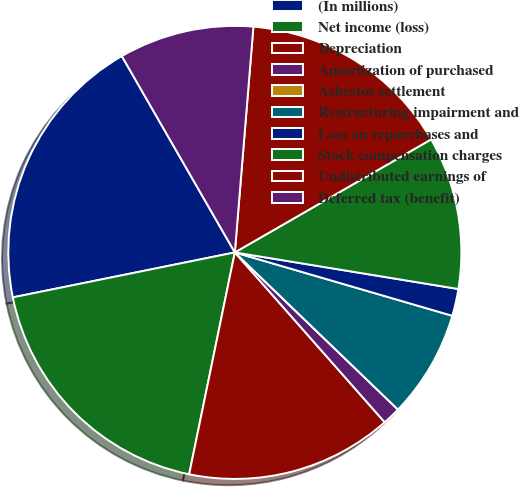Convert chart to OTSL. <chart><loc_0><loc_0><loc_500><loc_500><pie_chart><fcel>(In millions)<fcel>Net income (loss)<fcel>Depreciation<fcel>Amortization of purchased<fcel>Asbestos settlement<fcel>Restructuring impairment and<fcel>Loss on repurchases and<fcel>Stock compensation charges<fcel>Undistributed earnings of<fcel>Deferred tax (benefit)<nl><fcel>19.87%<fcel>18.59%<fcel>14.74%<fcel>1.29%<fcel>0.0%<fcel>7.69%<fcel>1.93%<fcel>10.9%<fcel>15.38%<fcel>9.62%<nl></chart> 